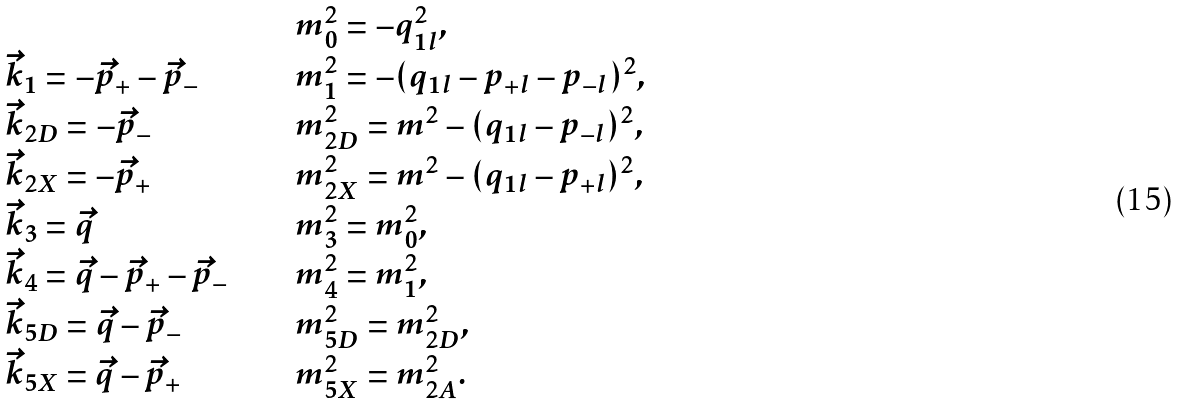Convert formula to latex. <formula><loc_0><loc_0><loc_500><loc_500>\begin{array} { l c l } & \quad & m _ { 0 } ^ { 2 } = - q _ { 1 l } ^ { 2 } , \\ \vec { k } _ { 1 } = - \vec { p } _ { + } - \vec { p } _ { - } & & m _ { 1 } ^ { 2 } = - ( q _ { 1 l } - p _ { + l } - p _ { - l } ) ^ { 2 } , \\ \vec { k } _ { 2 D } = - \vec { p } _ { - } & & m _ { 2 D } ^ { 2 } = m ^ { 2 } - ( q _ { 1 l } - p _ { - l } ) ^ { 2 } , \\ \vec { k } _ { 2 X } = - \vec { p } _ { + } & & m _ { 2 X } ^ { 2 } = m ^ { 2 } - ( q _ { 1 l } - p _ { + l } ) ^ { 2 } , \\ \vec { k } _ { 3 } = \vec { q } & & m _ { 3 } ^ { 2 } = m _ { 0 } ^ { 2 } , \\ \vec { k } _ { 4 } = \vec { q } - \vec { p } _ { + } - \vec { p } _ { - } & & m _ { 4 } ^ { 2 } = m _ { 1 } ^ { 2 } , \\ \vec { k } _ { 5 D } = \vec { q } - \vec { p } _ { - } & & m _ { 5 D } ^ { 2 } = m _ { 2 D } ^ { 2 } , \\ \vec { k } _ { 5 X } = \vec { q } - \vec { p } _ { + } & & m _ { 5 X } ^ { 2 } = m _ { 2 A } ^ { 2 } . \end{array}</formula> 